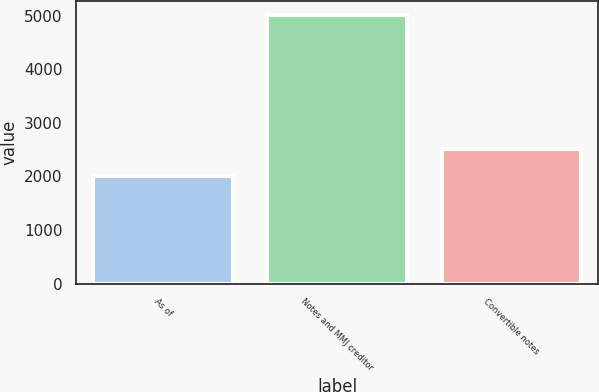<chart> <loc_0><loc_0><loc_500><loc_500><bar_chart><fcel>As of<fcel>Notes and MMJ creditor<fcel>Convertible notes<nl><fcel>2015<fcel>5020<fcel>2508<nl></chart> 